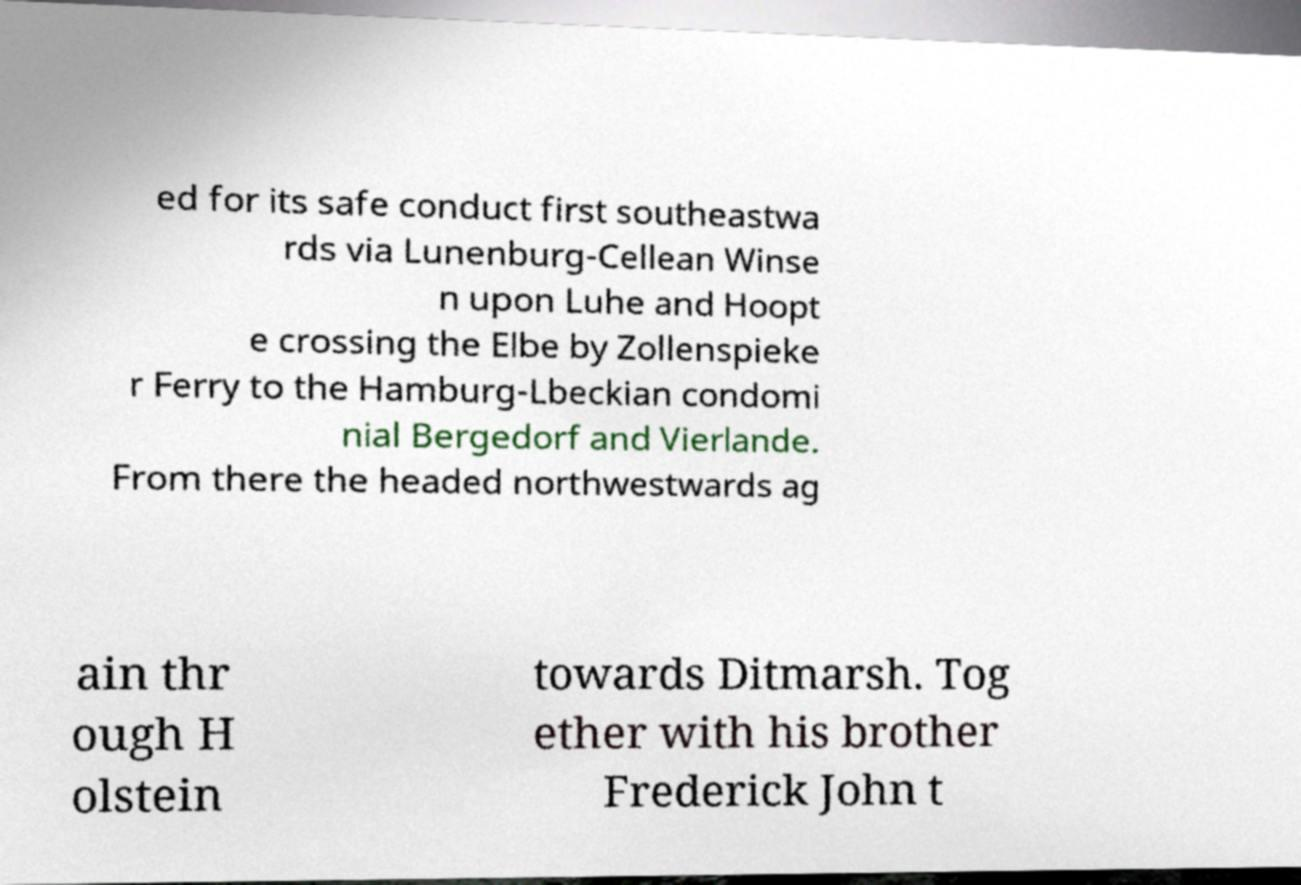Can you accurately transcribe the text from the provided image for me? ed for its safe conduct first southeastwa rds via Lunenburg-Cellean Winse n upon Luhe and Hoopt e crossing the Elbe by Zollenspieke r Ferry to the Hamburg-Lbeckian condomi nial Bergedorf and Vierlande. From there the headed northwestwards ag ain thr ough H olstein towards Ditmarsh. Tog ether with his brother Frederick John t 